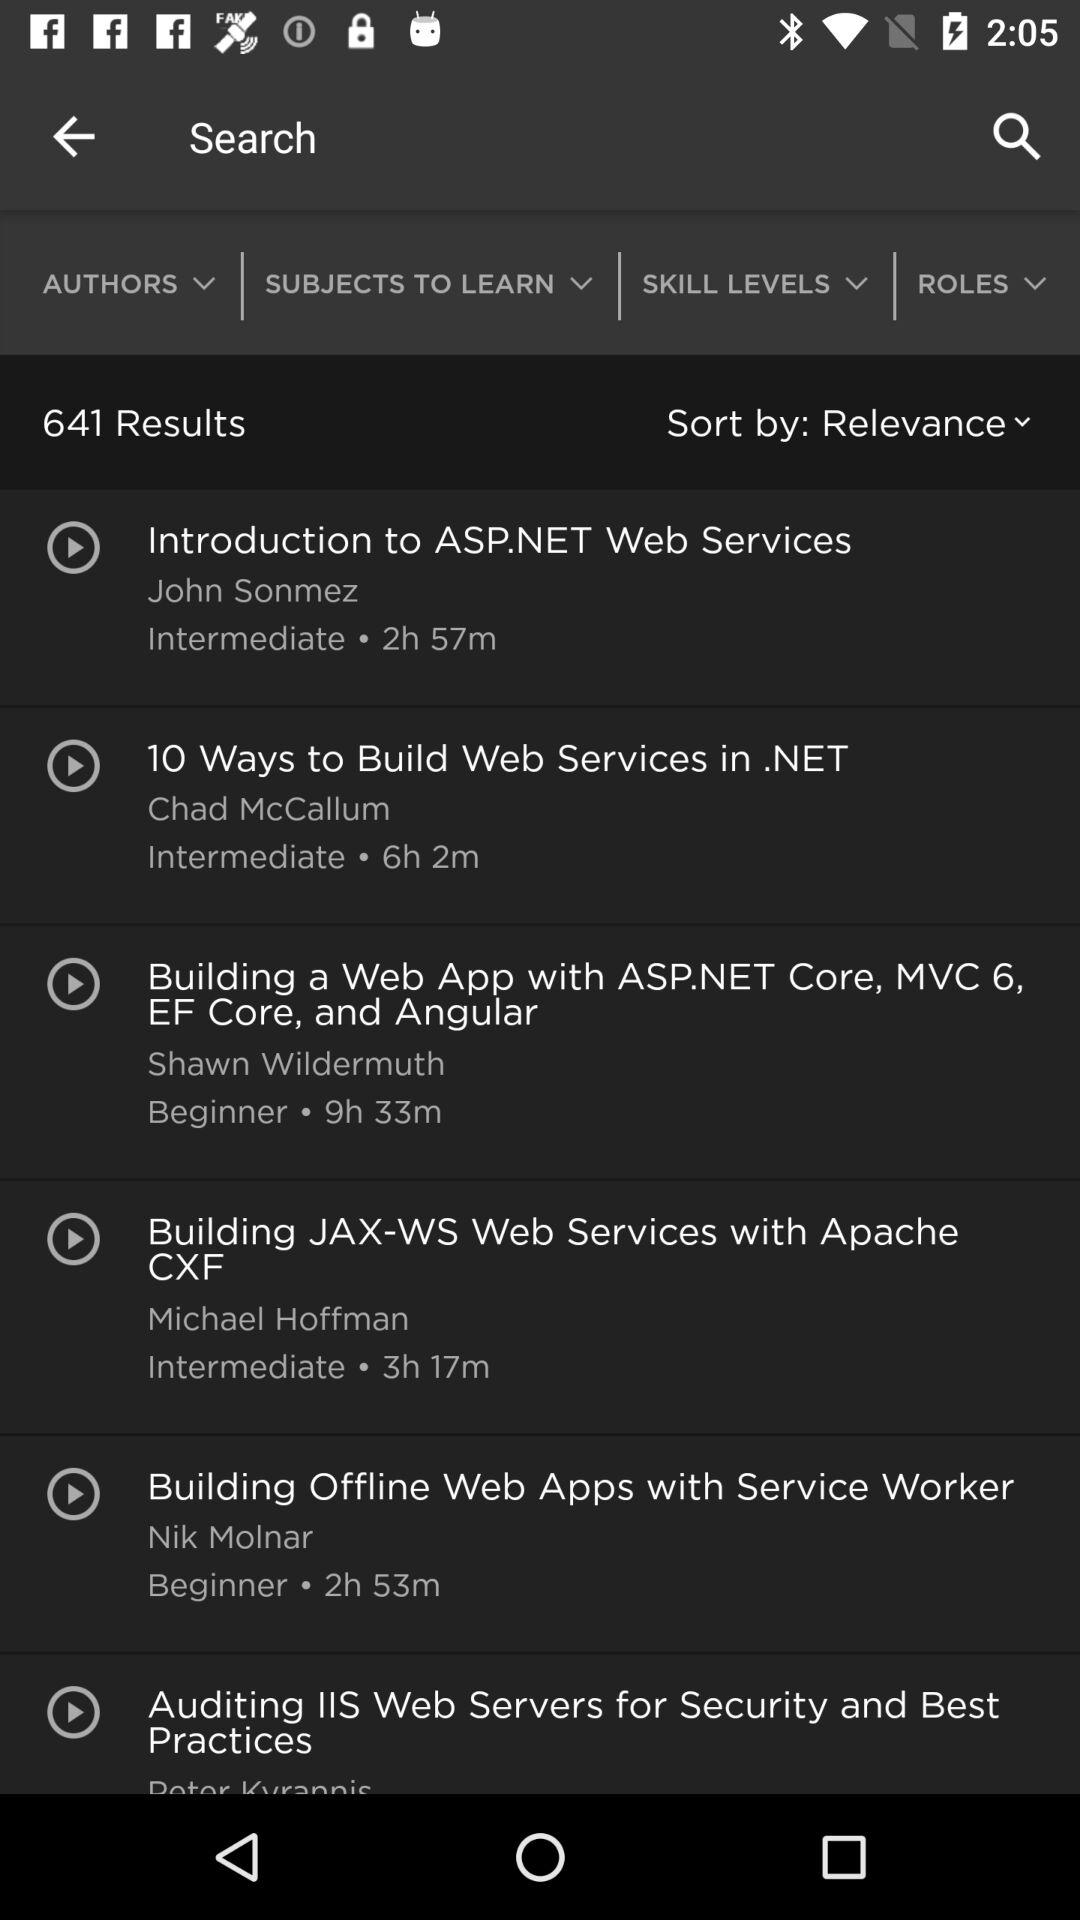What is the name of the author of "Building Offline Web Apps with Service Worker"? The name of the author is Nik Molnar. 